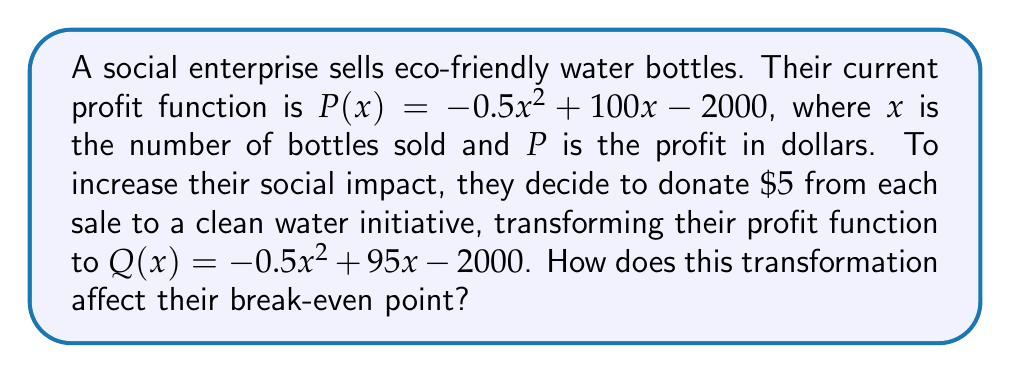Solve this math problem. 1) First, let's find the break-even points for both functions:

   For $P(x)$:
   $-0.5x^2 + 100x - 2000 = 0$
   $-0.5(x^2 - 200x + 4000) = 0$
   $-0.5(x - 20)(x - 180) = 0$
   $x = 20$ or $x = 180$

   For $Q(x)$:
   $-0.5x^2 + 95x - 2000 = 0$
   $-0.5(x^2 - 190x + 4000) = 0$
   $-0.5(x - 20)(x - 170) = 0$
   $x = 20$ or $x = 170$

2) The break-even points are where the profit functions cross the x-axis (i.e., where profit is zero).

3) For $P(x)$, the break-even points are at $x = 20$ and $x = 180$.
   For $Q(x)$, the break-even points are at $x = 20$ and $x = 170$.

4) The lower break-even point remains the same (20 bottles), but the upper break-even point has decreased by 10 bottles (from 180 to 170).

5) This means that the social enterprise now needs to sell 10 fewer bottles to reach their maximum break-even point, but their profitable range has decreased by 10 bottles.
Answer: The transformation decreases the upper break-even point by 10 bottles, from 180 to 170, while the lower break-even point remains at 20 bottles. 